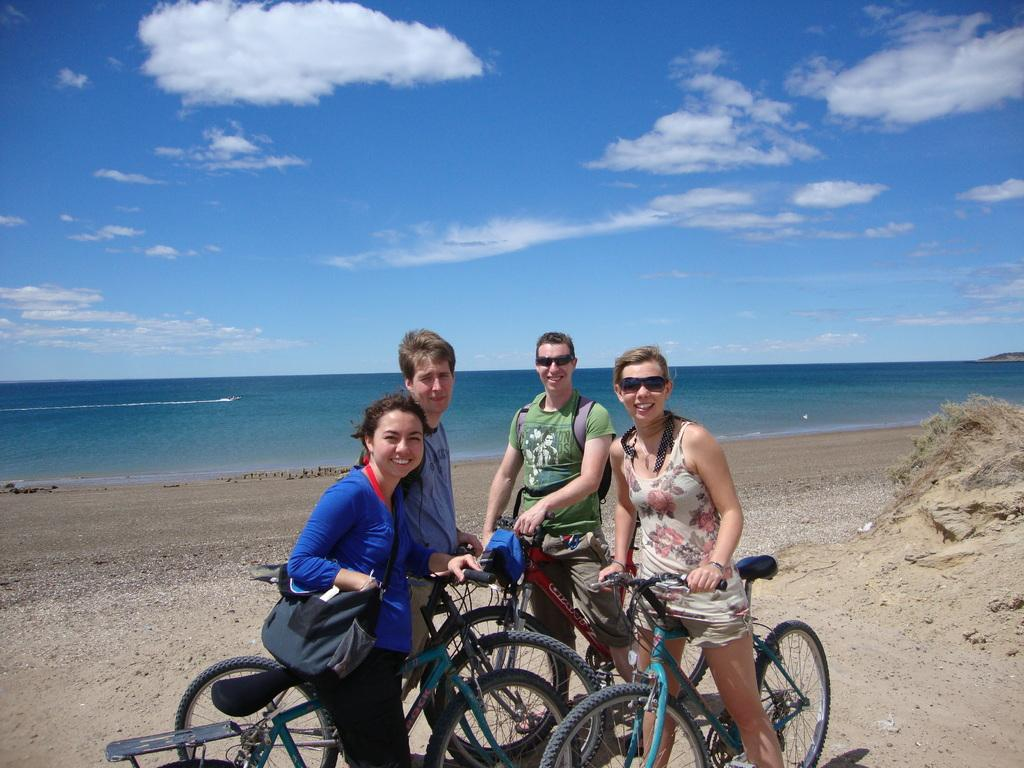How many people are in the image? There are 2 women and 2 men in the image, making a total of 4 people. What is the facial expression of the people in the image? All the people in the image are smiling. What activity are the people engaged in? All the people in the image are with their cycles. What can be seen in the background of the image? There is sand, water, and the sky visible in the background of the image. How many times do the women jump in the image? There is no jumping activity depicted in the image. What type of teeth can be seen in the image? There are no teeth visible in the image, as it features people with their cycles and the focus is not on their dental features. 